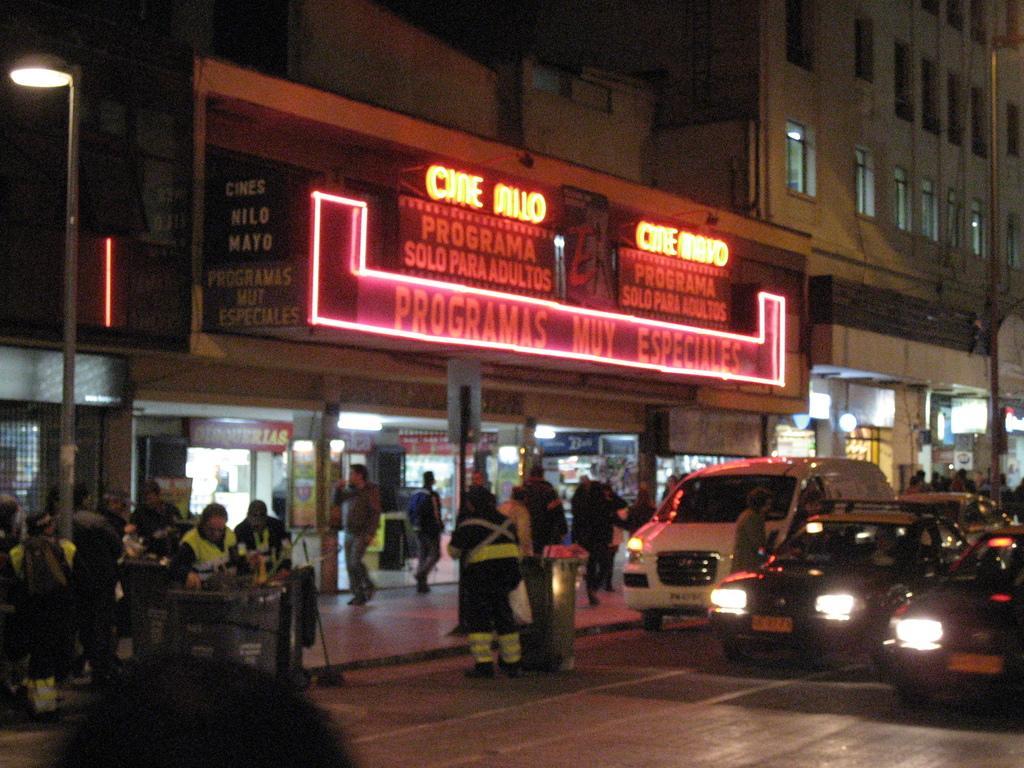In one or two sentences, can you explain what this image depicts? This is a image taken outside a city. In the foreground of the picture on the road, there are vehicles. On the left there is a footpath, on the footpath there are people walking, on the footpath there are dustbins and street light. At the top there are buildings, windows hoardings and lights. 